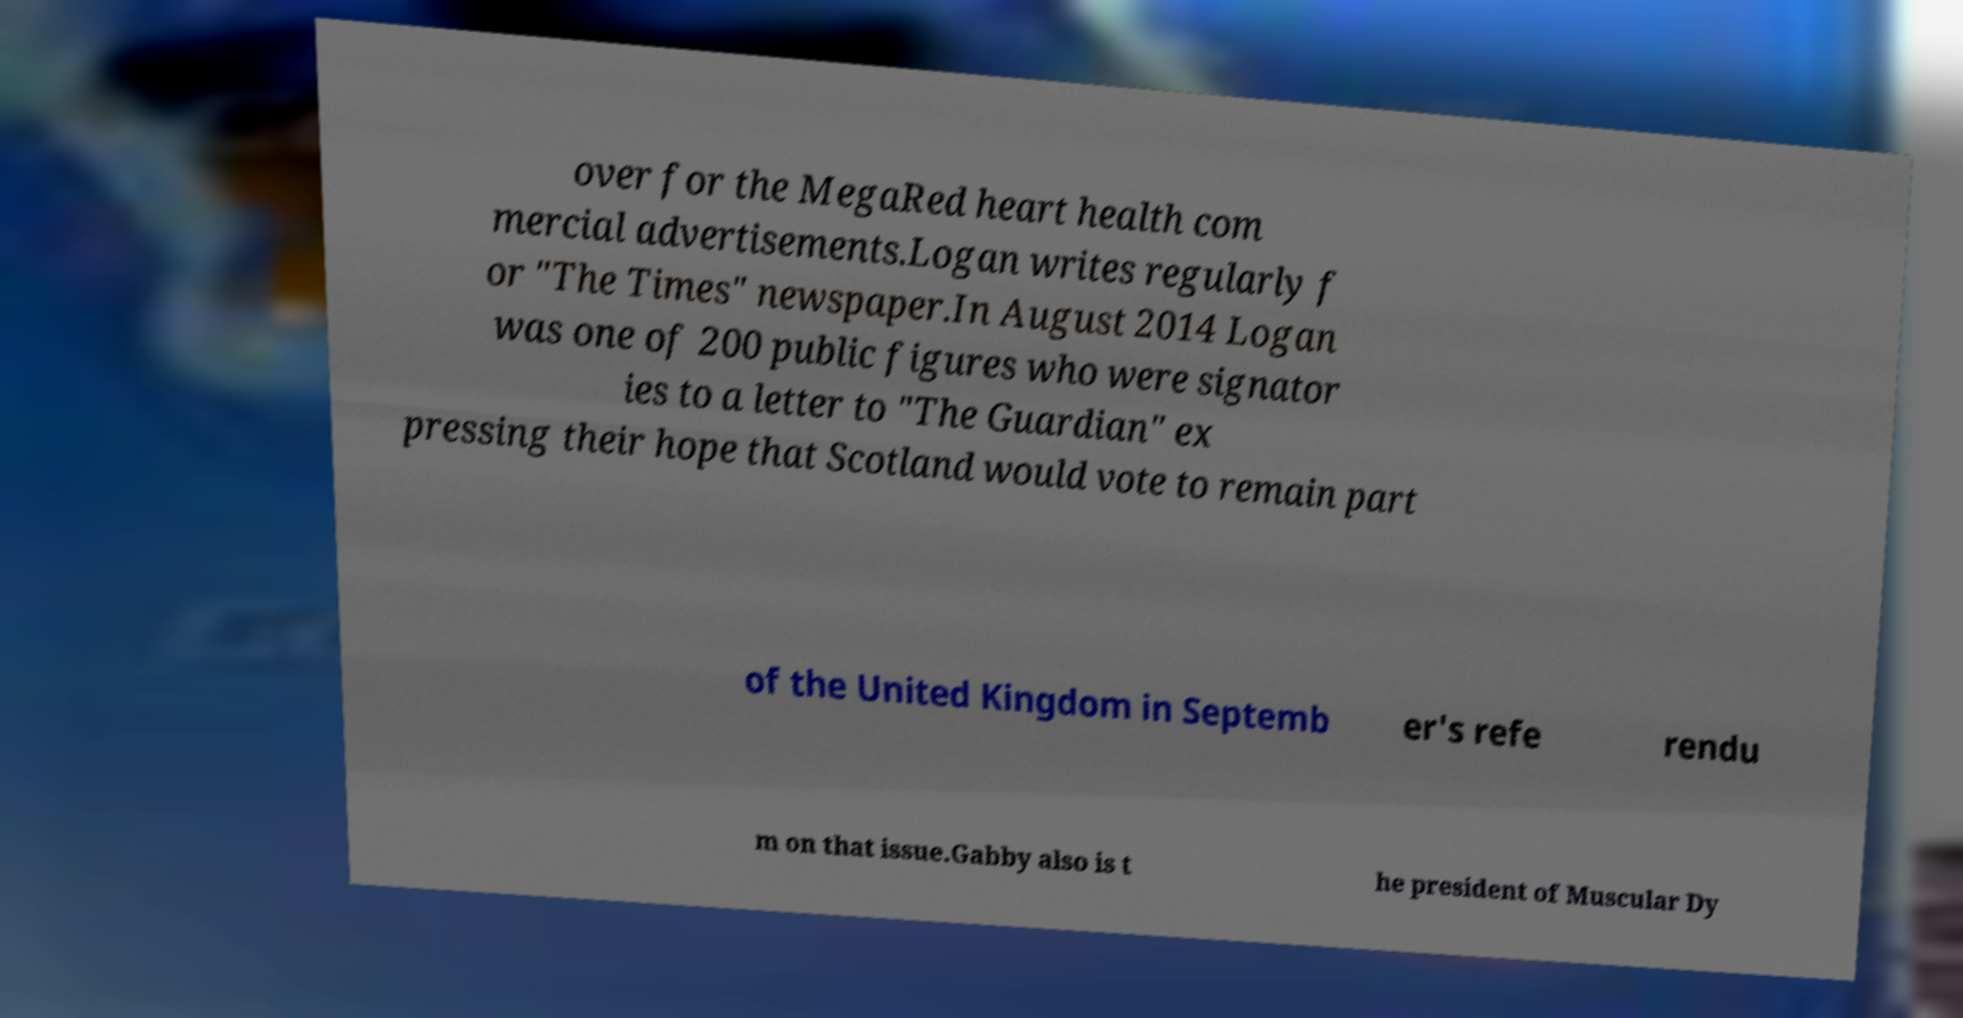What messages or text are displayed in this image? I need them in a readable, typed format. over for the MegaRed heart health com mercial advertisements.Logan writes regularly f or "The Times" newspaper.In August 2014 Logan was one of 200 public figures who were signator ies to a letter to "The Guardian" ex pressing their hope that Scotland would vote to remain part of the United Kingdom in Septemb er's refe rendu m on that issue.Gabby also is t he president of Muscular Dy 